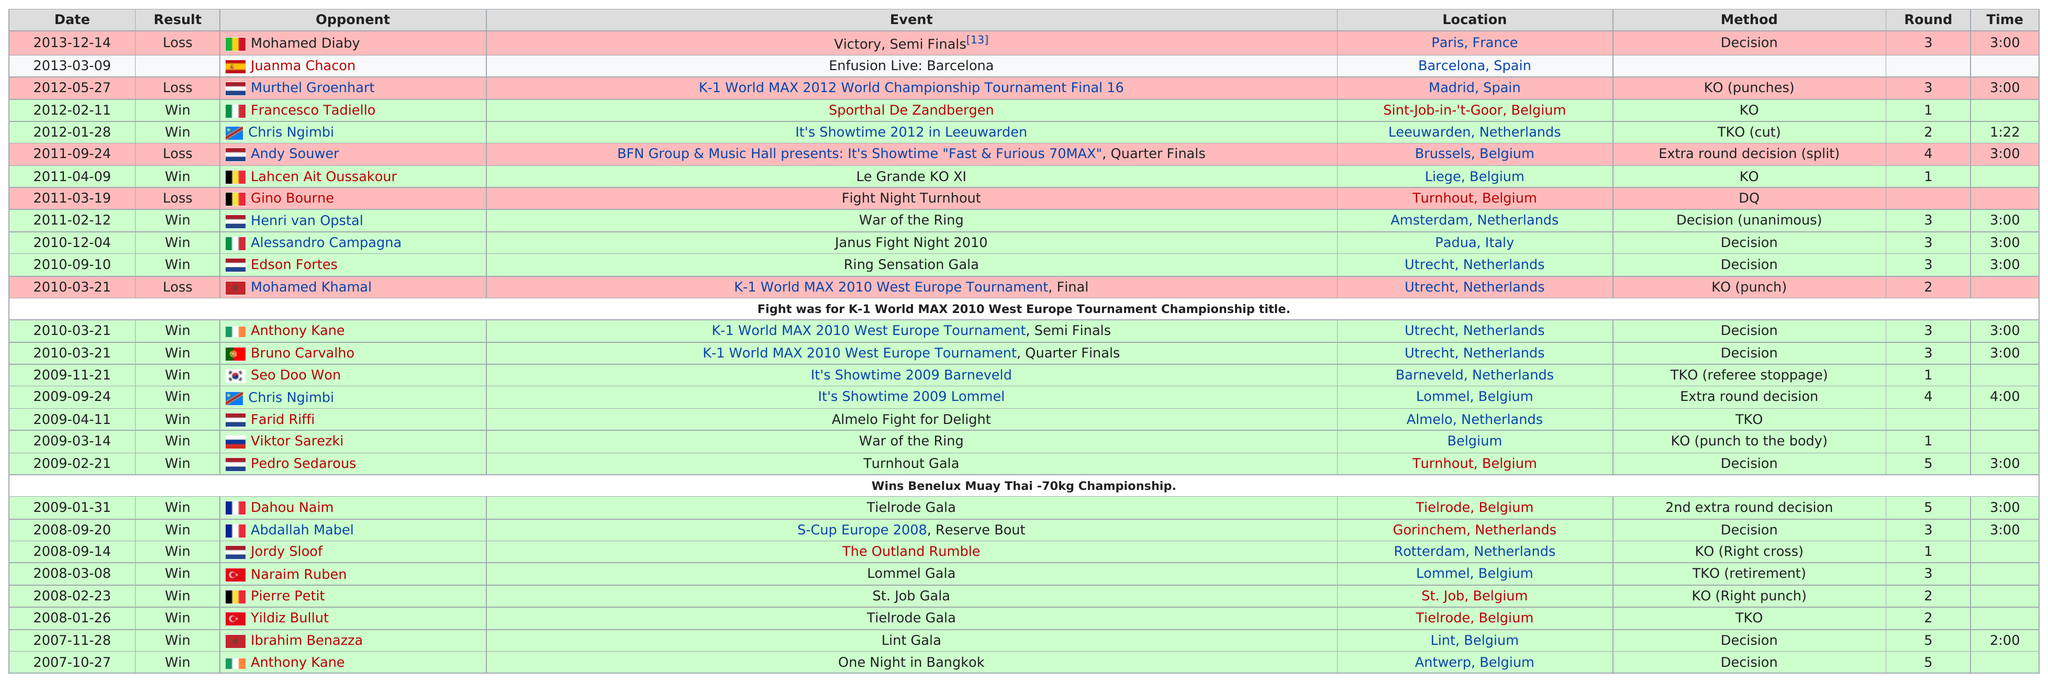Draw attention to some important aspects in this diagram. The event that lasted the longest time was "It's Showtime 2009 Lommel. Nine events lasted three rounds. The shortest event lasted for 1 minute and 22 seconds. The fight against Ibrahim Benazza lasted for a total of 5 rounds. Grigorian had a match in Belgium 13 times. 